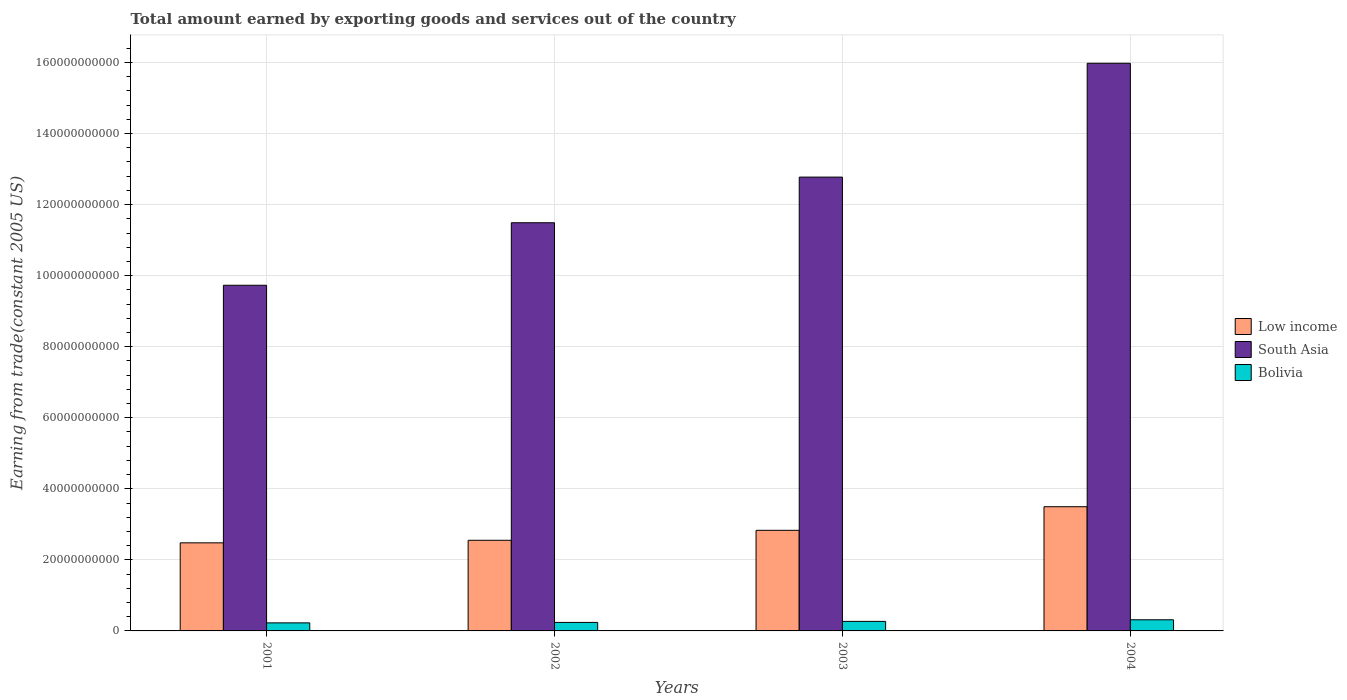What is the label of the 2nd group of bars from the left?
Ensure brevity in your answer.  2002. What is the total amount earned by exporting goods and services in Low income in 2002?
Your answer should be compact. 2.55e+1. Across all years, what is the maximum total amount earned by exporting goods and services in Bolivia?
Make the answer very short. 3.13e+09. Across all years, what is the minimum total amount earned by exporting goods and services in South Asia?
Provide a short and direct response. 9.73e+1. In which year was the total amount earned by exporting goods and services in Bolivia maximum?
Offer a very short reply. 2004. In which year was the total amount earned by exporting goods and services in Bolivia minimum?
Provide a short and direct response. 2001. What is the total total amount earned by exporting goods and services in Bolivia in the graph?
Provide a succinct answer. 1.05e+1. What is the difference between the total amount earned by exporting goods and services in Bolivia in 2001 and that in 2002?
Provide a succinct answer. -1.29e+08. What is the difference between the total amount earned by exporting goods and services in South Asia in 2003 and the total amount earned by exporting goods and services in Low income in 2001?
Keep it short and to the point. 1.03e+11. What is the average total amount earned by exporting goods and services in South Asia per year?
Provide a short and direct response. 1.25e+11. In the year 2002, what is the difference between the total amount earned by exporting goods and services in South Asia and total amount earned by exporting goods and services in Low income?
Your answer should be compact. 8.94e+1. What is the ratio of the total amount earned by exporting goods and services in Bolivia in 2002 to that in 2004?
Provide a short and direct response. 0.76. Is the difference between the total amount earned by exporting goods and services in South Asia in 2002 and 2003 greater than the difference between the total amount earned by exporting goods and services in Low income in 2002 and 2003?
Provide a short and direct response. No. What is the difference between the highest and the second highest total amount earned by exporting goods and services in Low income?
Your answer should be compact. 6.65e+09. What is the difference between the highest and the lowest total amount earned by exporting goods and services in South Asia?
Provide a short and direct response. 6.25e+1. In how many years, is the total amount earned by exporting goods and services in Low income greater than the average total amount earned by exporting goods and services in Low income taken over all years?
Offer a very short reply. 1. How many bars are there?
Offer a terse response. 12. What is the difference between two consecutive major ticks on the Y-axis?
Offer a terse response. 2.00e+1. Does the graph contain any zero values?
Keep it short and to the point. No. Where does the legend appear in the graph?
Make the answer very short. Center right. How many legend labels are there?
Ensure brevity in your answer.  3. What is the title of the graph?
Keep it short and to the point. Total amount earned by exporting goods and services out of the country. Does "Lao PDR" appear as one of the legend labels in the graph?
Your answer should be very brief. No. What is the label or title of the Y-axis?
Provide a short and direct response. Earning from trade(constant 2005 US). What is the Earning from trade(constant 2005 US) of Low income in 2001?
Provide a succinct answer. 2.48e+1. What is the Earning from trade(constant 2005 US) in South Asia in 2001?
Your answer should be compact. 9.73e+1. What is the Earning from trade(constant 2005 US) in Bolivia in 2001?
Give a very brief answer. 2.27e+09. What is the Earning from trade(constant 2005 US) in Low income in 2002?
Provide a short and direct response. 2.55e+1. What is the Earning from trade(constant 2005 US) in South Asia in 2002?
Your answer should be compact. 1.15e+11. What is the Earning from trade(constant 2005 US) of Bolivia in 2002?
Provide a short and direct response. 2.40e+09. What is the Earning from trade(constant 2005 US) in Low income in 2003?
Offer a terse response. 2.83e+1. What is the Earning from trade(constant 2005 US) of South Asia in 2003?
Your answer should be compact. 1.28e+11. What is the Earning from trade(constant 2005 US) of Bolivia in 2003?
Provide a short and direct response. 2.69e+09. What is the Earning from trade(constant 2005 US) of Low income in 2004?
Your answer should be compact. 3.50e+1. What is the Earning from trade(constant 2005 US) of South Asia in 2004?
Your answer should be very brief. 1.60e+11. What is the Earning from trade(constant 2005 US) of Bolivia in 2004?
Give a very brief answer. 3.13e+09. Across all years, what is the maximum Earning from trade(constant 2005 US) in Low income?
Offer a very short reply. 3.50e+1. Across all years, what is the maximum Earning from trade(constant 2005 US) of South Asia?
Your answer should be compact. 1.60e+11. Across all years, what is the maximum Earning from trade(constant 2005 US) of Bolivia?
Your answer should be compact. 3.13e+09. Across all years, what is the minimum Earning from trade(constant 2005 US) of Low income?
Ensure brevity in your answer.  2.48e+1. Across all years, what is the minimum Earning from trade(constant 2005 US) of South Asia?
Give a very brief answer. 9.73e+1. Across all years, what is the minimum Earning from trade(constant 2005 US) in Bolivia?
Make the answer very short. 2.27e+09. What is the total Earning from trade(constant 2005 US) of Low income in the graph?
Your answer should be very brief. 1.14e+11. What is the total Earning from trade(constant 2005 US) in South Asia in the graph?
Ensure brevity in your answer.  5.00e+11. What is the total Earning from trade(constant 2005 US) of Bolivia in the graph?
Your answer should be compact. 1.05e+1. What is the difference between the Earning from trade(constant 2005 US) of Low income in 2001 and that in 2002?
Provide a succinct answer. -7.19e+08. What is the difference between the Earning from trade(constant 2005 US) in South Asia in 2001 and that in 2002?
Your answer should be compact. -1.76e+1. What is the difference between the Earning from trade(constant 2005 US) of Bolivia in 2001 and that in 2002?
Give a very brief answer. -1.29e+08. What is the difference between the Earning from trade(constant 2005 US) in Low income in 2001 and that in 2003?
Your answer should be compact. -3.52e+09. What is the difference between the Earning from trade(constant 2005 US) in South Asia in 2001 and that in 2003?
Give a very brief answer. -3.04e+1. What is the difference between the Earning from trade(constant 2005 US) of Bolivia in 2001 and that in 2003?
Your answer should be very brief. -4.20e+08. What is the difference between the Earning from trade(constant 2005 US) in Low income in 2001 and that in 2004?
Make the answer very short. -1.02e+1. What is the difference between the Earning from trade(constant 2005 US) of South Asia in 2001 and that in 2004?
Offer a terse response. -6.25e+1. What is the difference between the Earning from trade(constant 2005 US) of Bolivia in 2001 and that in 2004?
Your answer should be compact. -8.67e+08. What is the difference between the Earning from trade(constant 2005 US) of Low income in 2002 and that in 2003?
Your answer should be compact. -2.81e+09. What is the difference between the Earning from trade(constant 2005 US) in South Asia in 2002 and that in 2003?
Ensure brevity in your answer.  -1.28e+1. What is the difference between the Earning from trade(constant 2005 US) in Bolivia in 2002 and that in 2003?
Provide a succinct answer. -2.91e+08. What is the difference between the Earning from trade(constant 2005 US) of Low income in 2002 and that in 2004?
Provide a short and direct response. -9.45e+09. What is the difference between the Earning from trade(constant 2005 US) in South Asia in 2002 and that in 2004?
Keep it short and to the point. -4.49e+1. What is the difference between the Earning from trade(constant 2005 US) of Bolivia in 2002 and that in 2004?
Keep it short and to the point. -7.38e+08. What is the difference between the Earning from trade(constant 2005 US) of Low income in 2003 and that in 2004?
Give a very brief answer. -6.65e+09. What is the difference between the Earning from trade(constant 2005 US) of South Asia in 2003 and that in 2004?
Your answer should be compact. -3.20e+1. What is the difference between the Earning from trade(constant 2005 US) in Bolivia in 2003 and that in 2004?
Give a very brief answer. -4.47e+08. What is the difference between the Earning from trade(constant 2005 US) of Low income in 2001 and the Earning from trade(constant 2005 US) of South Asia in 2002?
Ensure brevity in your answer.  -9.01e+1. What is the difference between the Earning from trade(constant 2005 US) in Low income in 2001 and the Earning from trade(constant 2005 US) in Bolivia in 2002?
Make the answer very short. 2.24e+1. What is the difference between the Earning from trade(constant 2005 US) of South Asia in 2001 and the Earning from trade(constant 2005 US) of Bolivia in 2002?
Provide a succinct answer. 9.49e+1. What is the difference between the Earning from trade(constant 2005 US) in Low income in 2001 and the Earning from trade(constant 2005 US) in South Asia in 2003?
Your response must be concise. -1.03e+11. What is the difference between the Earning from trade(constant 2005 US) in Low income in 2001 and the Earning from trade(constant 2005 US) in Bolivia in 2003?
Provide a succinct answer. 2.21e+1. What is the difference between the Earning from trade(constant 2005 US) in South Asia in 2001 and the Earning from trade(constant 2005 US) in Bolivia in 2003?
Ensure brevity in your answer.  9.46e+1. What is the difference between the Earning from trade(constant 2005 US) in Low income in 2001 and the Earning from trade(constant 2005 US) in South Asia in 2004?
Your answer should be compact. -1.35e+11. What is the difference between the Earning from trade(constant 2005 US) in Low income in 2001 and the Earning from trade(constant 2005 US) in Bolivia in 2004?
Provide a short and direct response. 2.17e+1. What is the difference between the Earning from trade(constant 2005 US) of South Asia in 2001 and the Earning from trade(constant 2005 US) of Bolivia in 2004?
Provide a succinct answer. 9.42e+1. What is the difference between the Earning from trade(constant 2005 US) of Low income in 2002 and the Earning from trade(constant 2005 US) of South Asia in 2003?
Offer a terse response. -1.02e+11. What is the difference between the Earning from trade(constant 2005 US) in Low income in 2002 and the Earning from trade(constant 2005 US) in Bolivia in 2003?
Your response must be concise. 2.28e+1. What is the difference between the Earning from trade(constant 2005 US) of South Asia in 2002 and the Earning from trade(constant 2005 US) of Bolivia in 2003?
Provide a succinct answer. 1.12e+11. What is the difference between the Earning from trade(constant 2005 US) in Low income in 2002 and the Earning from trade(constant 2005 US) in South Asia in 2004?
Your answer should be compact. -1.34e+11. What is the difference between the Earning from trade(constant 2005 US) in Low income in 2002 and the Earning from trade(constant 2005 US) in Bolivia in 2004?
Your answer should be compact. 2.24e+1. What is the difference between the Earning from trade(constant 2005 US) in South Asia in 2002 and the Earning from trade(constant 2005 US) in Bolivia in 2004?
Make the answer very short. 1.12e+11. What is the difference between the Earning from trade(constant 2005 US) of Low income in 2003 and the Earning from trade(constant 2005 US) of South Asia in 2004?
Provide a short and direct response. -1.31e+11. What is the difference between the Earning from trade(constant 2005 US) in Low income in 2003 and the Earning from trade(constant 2005 US) in Bolivia in 2004?
Provide a short and direct response. 2.52e+1. What is the difference between the Earning from trade(constant 2005 US) in South Asia in 2003 and the Earning from trade(constant 2005 US) in Bolivia in 2004?
Ensure brevity in your answer.  1.25e+11. What is the average Earning from trade(constant 2005 US) of Low income per year?
Make the answer very short. 2.84e+1. What is the average Earning from trade(constant 2005 US) of South Asia per year?
Offer a terse response. 1.25e+11. What is the average Earning from trade(constant 2005 US) in Bolivia per year?
Keep it short and to the point. 2.62e+09. In the year 2001, what is the difference between the Earning from trade(constant 2005 US) of Low income and Earning from trade(constant 2005 US) of South Asia?
Your answer should be very brief. -7.25e+1. In the year 2001, what is the difference between the Earning from trade(constant 2005 US) of Low income and Earning from trade(constant 2005 US) of Bolivia?
Provide a succinct answer. 2.25e+1. In the year 2001, what is the difference between the Earning from trade(constant 2005 US) in South Asia and Earning from trade(constant 2005 US) in Bolivia?
Ensure brevity in your answer.  9.50e+1. In the year 2002, what is the difference between the Earning from trade(constant 2005 US) in Low income and Earning from trade(constant 2005 US) in South Asia?
Provide a short and direct response. -8.94e+1. In the year 2002, what is the difference between the Earning from trade(constant 2005 US) of Low income and Earning from trade(constant 2005 US) of Bolivia?
Your answer should be very brief. 2.31e+1. In the year 2002, what is the difference between the Earning from trade(constant 2005 US) of South Asia and Earning from trade(constant 2005 US) of Bolivia?
Offer a terse response. 1.12e+11. In the year 2003, what is the difference between the Earning from trade(constant 2005 US) of Low income and Earning from trade(constant 2005 US) of South Asia?
Provide a succinct answer. -9.94e+1. In the year 2003, what is the difference between the Earning from trade(constant 2005 US) of Low income and Earning from trade(constant 2005 US) of Bolivia?
Your response must be concise. 2.56e+1. In the year 2003, what is the difference between the Earning from trade(constant 2005 US) in South Asia and Earning from trade(constant 2005 US) in Bolivia?
Provide a succinct answer. 1.25e+11. In the year 2004, what is the difference between the Earning from trade(constant 2005 US) in Low income and Earning from trade(constant 2005 US) in South Asia?
Offer a terse response. -1.25e+11. In the year 2004, what is the difference between the Earning from trade(constant 2005 US) in Low income and Earning from trade(constant 2005 US) in Bolivia?
Your answer should be compact. 3.18e+1. In the year 2004, what is the difference between the Earning from trade(constant 2005 US) of South Asia and Earning from trade(constant 2005 US) of Bolivia?
Make the answer very short. 1.57e+11. What is the ratio of the Earning from trade(constant 2005 US) in Low income in 2001 to that in 2002?
Offer a terse response. 0.97. What is the ratio of the Earning from trade(constant 2005 US) in South Asia in 2001 to that in 2002?
Make the answer very short. 0.85. What is the ratio of the Earning from trade(constant 2005 US) of Bolivia in 2001 to that in 2002?
Ensure brevity in your answer.  0.95. What is the ratio of the Earning from trade(constant 2005 US) of Low income in 2001 to that in 2003?
Offer a terse response. 0.88. What is the ratio of the Earning from trade(constant 2005 US) in South Asia in 2001 to that in 2003?
Your answer should be very brief. 0.76. What is the ratio of the Earning from trade(constant 2005 US) in Bolivia in 2001 to that in 2003?
Your answer should be compact. 0.84. What is the ratio of the Earning from trade(constant 2005 US) in Low income in 2001 to that in 2004?
Give a very brief answer. 0.71. What is the ratio of the Earning from trade(constant 2005 US) of South Asia in 2001 to that in 2004?
Keep it short and to the point. 0.61. What is the ratio of the Earning from trade(constant 2005 US) in Bolivia in 2001 to that in 2004?
Provide a short and direct response. 0.72. What is the ratio of the Earning from trade(constant 2005 US) in Low income in 2002 to that in 2003?
Give a very brief answer. 0.9. What is the ratio of the Earning from trade(constant 2005 US) of South Asia in 2002 to that in 2003?
Give a very brief answer. 0.9. What is the ratio of the Earning from trade(constant 2005 US) of Bolivia in 2002 to that in 2003?
Offer a terse response. 0.89. What is the ratio of the Earning from trade(constant 2005 US) in Low income in 2002 to that in 2004?
Offer a terse response. 0.73. What is the ratio of the Earning from trade(constant 2005 US) of South Asia in 2002 to that in 2004?
Keep it short and to the point. 0.72. What is the ratio of the Earning from trade(constant 2005 US) of Bolivia in 2002 to that in 2004?
Offer a very short reply. 0.76. What is the ratio of the Earning from trade(constant 2005 US) in Low income in 2003 to that in 2004?
Keep it short and to the point. 0.81. What is the ratio of the Earning from trade(constant 2005 US) of South Asia in 2003 to that in 2004?
Provide a succinct answer. 0.8. What is the ratio of the Earning from trade(constant 2005 US) of Bolivia in 2003 to that in 2004?
Give a very brief answer. 0.86. What is the difference between the highest and the second highest Earning from trade(constant 2005 US) in Low income?
Give a very brief answer. 6.65e+09. What is the difference between the highest and the second highest Earning from trade(constant 2005 US) in South Asia?
Your answer should be very brief. 3.20e+1. What is the difference between the highest and the second highest Earning from trade(constant 2005 US) of Bolivia?
Your response must be concise. 4.47e+08. What is the difference between the highest and the lowest Earning from trade(constant 2005 US) of Low income?
Ensure brevity in your answer.  1.02e+1. What is the difference between the highest and the lowest Earning from trade(constant 2005 US) of South Asia?
Your response must be concise. 6.25e+1. What is the difference between the highest and the lowest Earning from trade(constant 2005 US) in Bolivia?
Provide a succinct answer. 8.67e+08. 